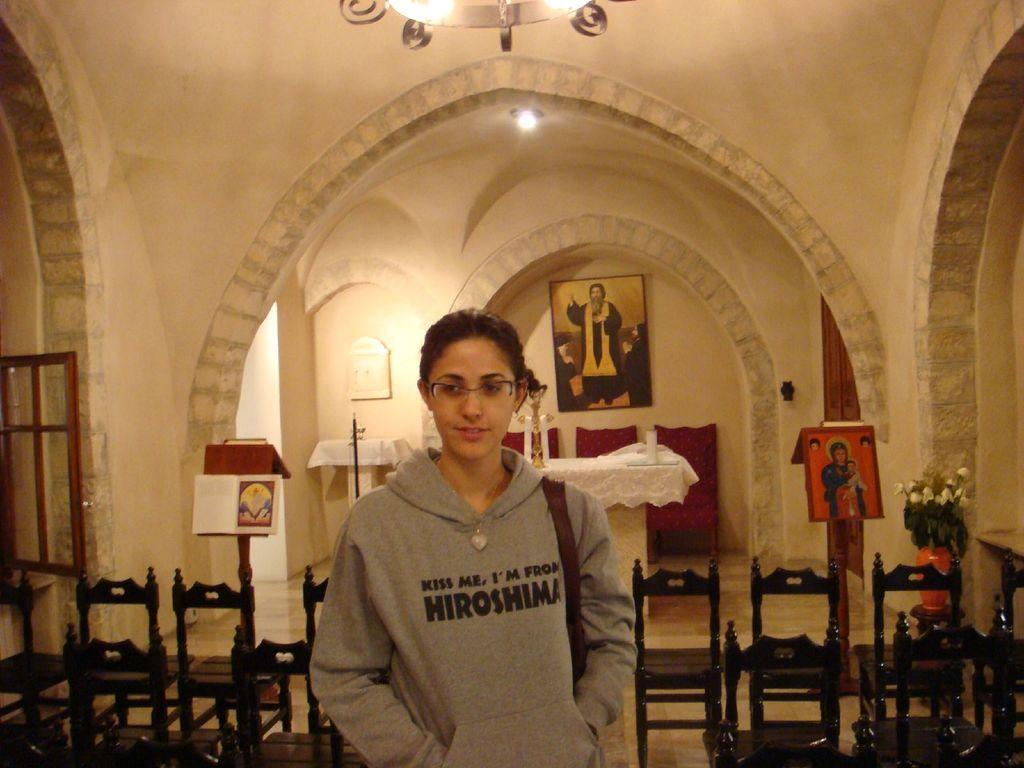Could you give a brief overview of what you see in this image? In front of the image there is a person standing. There are chairs, boards, tables. On top of the tables there are some objects. On the right side of the image there is a flower pot on the table. In the background of the image there are photo frames on the wall. On the left side of the image there is a window. At the bottom of the image there is a floor. On top of the image there is a chandelier and a light. 